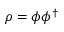Convert formula to latex. <formula><loc_0><loc_0><loc_500><loc_500>\rho = \phi \phi ^ { \dagger }</formula> 